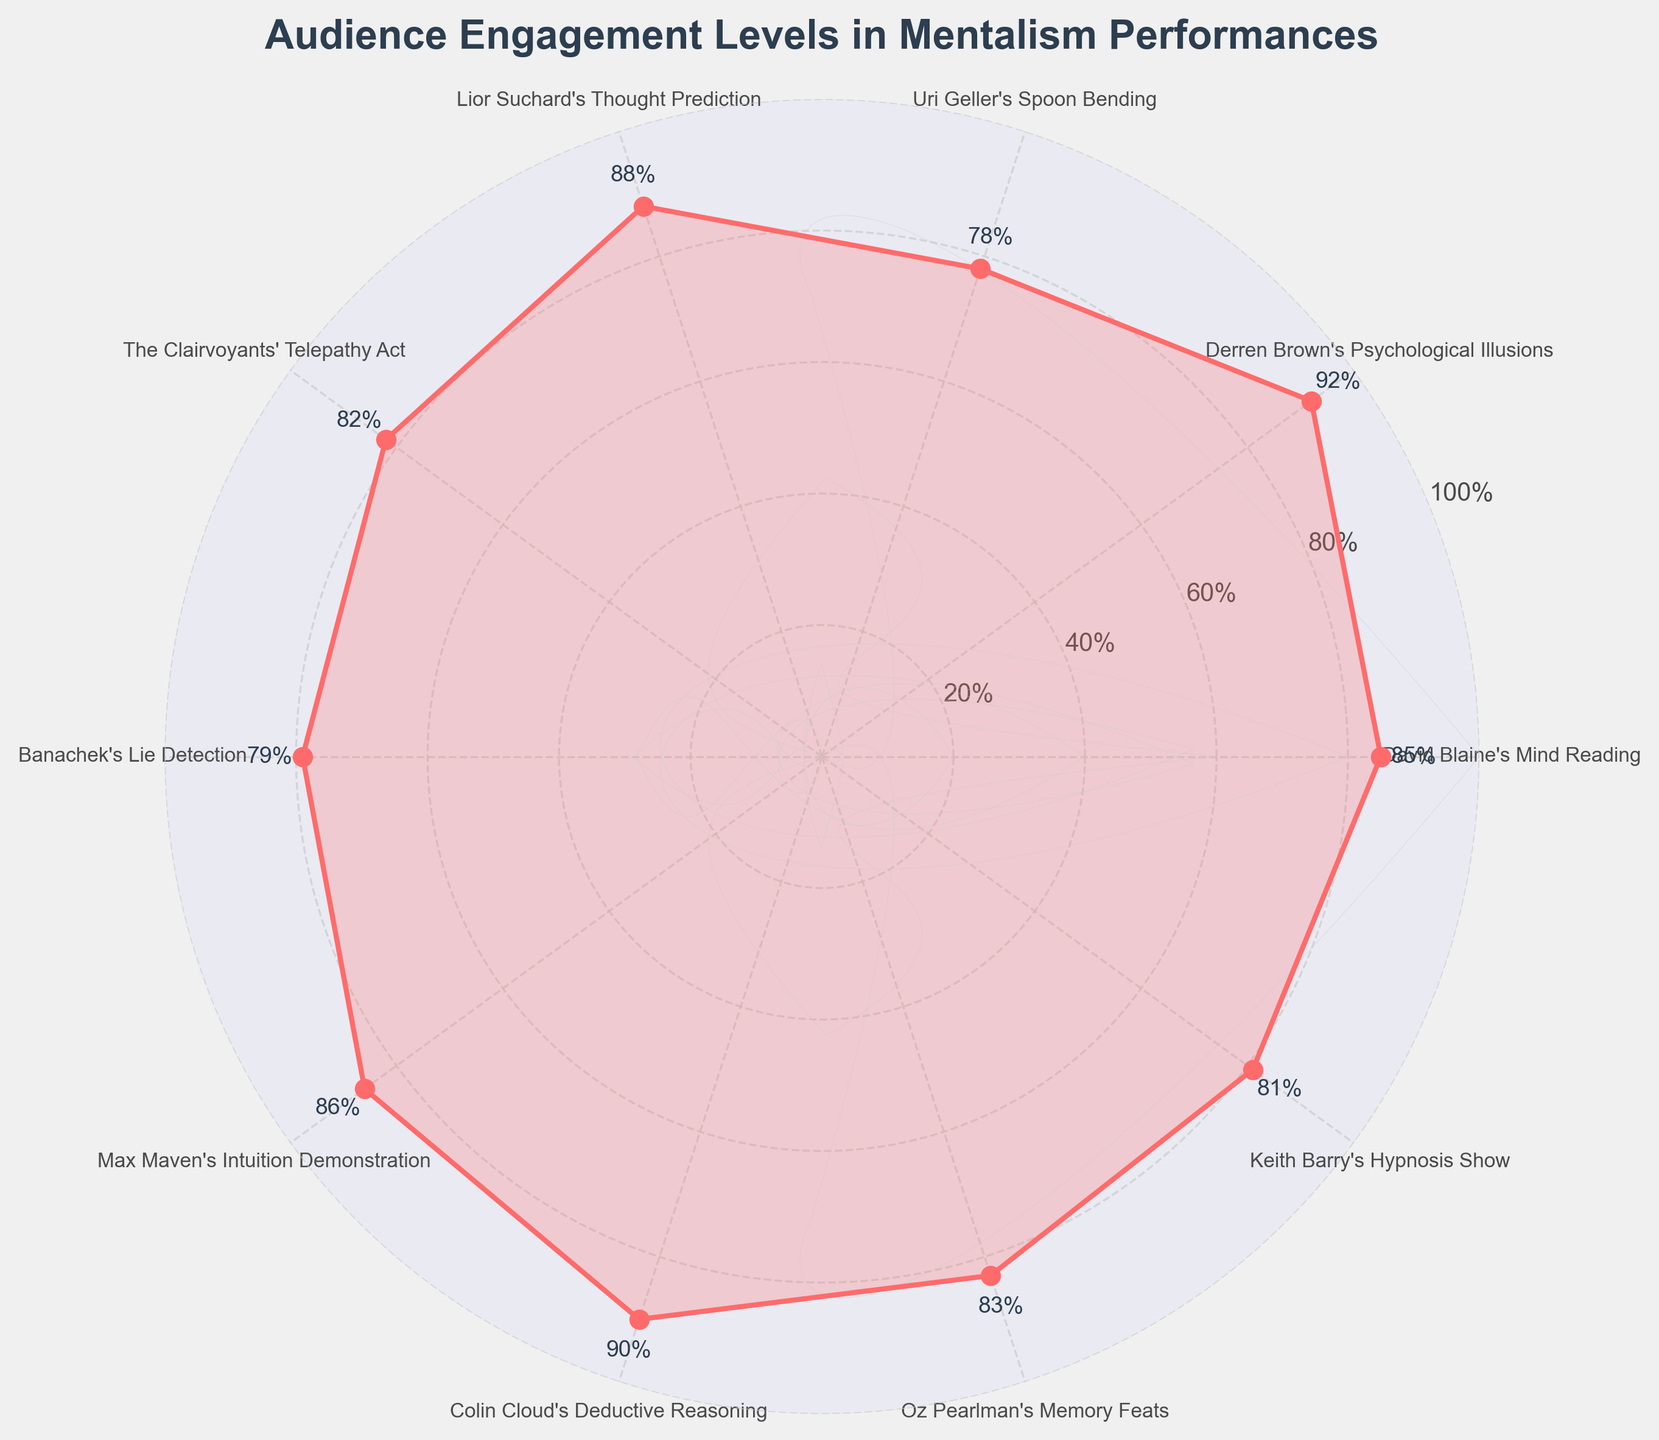What's the title of the figure? The title is usually prominently displayed at the top of the figure. Here, it reads "Audience Engagement Levels in Mentalism Performances"
Answer: Audience Engagement Levels in Mentalism Performances Which performance had the highest audience engagement level? By looking at the engagement values on the plot, the highest value is 92%, which corresponds to Derren Brown's Psychological Illusions
Answer: Derren Brown's Psychological Illusions What is the average engagement level across all performances? To find the average, sum all engagement levels and divide by the number of performances: (85+92+78+88+82+79+86+90+83+81)/10 = 84.4
Answer: 84.4% Which two performances have the closest engagement levels? Comparing the engagement levels visually, David Blaine's Mind Reading (85%) and Max Maven's Intuition Demonstration (86%) are closest with a 1% difference
Answer: David Blaine's Mind Reading and Max Maven's Intuition Demonstration How does Colin Cloud's engagement level compare to Lior Suchard's? Colin Cloud's Deductive Reasoning has 90% and Lior Suchard's Thought Prediction has 88%. So, Colin Cloud's engagement is 2% higher
Answer: Colin Cloud's Deductive Reasoning is 2% higher Between Banachek's Lie Detection and Uri Geller's Spoon Bending, which one has higher engagement? Banachek's Lie Detection has an engagement level of 79%, and Uri Geller's Spoon Bending has 78%. Therefore, Banachek's engagement is higher by 1%
Answer: Banachek's Lie Detection What's the percentage difference between the highest and lowest engagement levels? The highest engagement level is 92% (Derren Brown's Psychological Illusions) and the lowest is 78% (Uri Geller's Spoon Bending). The percentage difference is 92% - 78% = 14%
Answer: 14% Are there any performances with exactly 80% engagement? By checking the engagement values around the radar plot, none of the performances have exactly 80% engagement
Answer: No How many performances have engagement levels above 85%? Derren Brown (92%), Lior Suchard (88%), Max Maven (86%), and Colin Cloud (90%) have engagement levels above 85%. That's 4 performances
Answer: 4 What is the median engagement level of all performances? To find the median, list all engagement levels in order: 78, 79, 81, 82, 83, 85, 86, 88, 90, 92. The median, the middle value in a sorted list of numbers, here is (83+85)/2 = 84
Answer: 84 